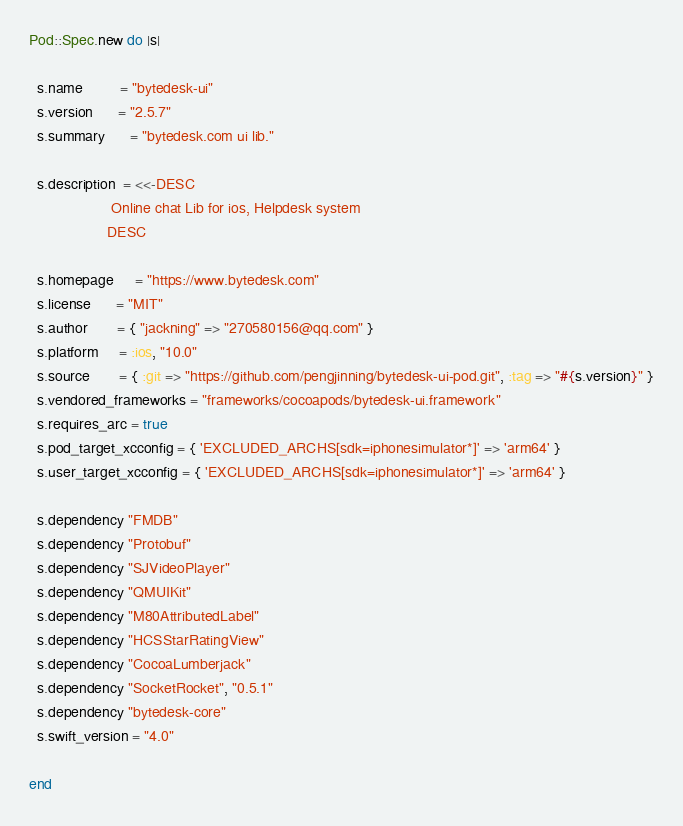Convert code to text. <code><loc_0><loc_0><loc_500><loc_500><_Ruby_>
Pod::Spec.new do |s|

  s.name         = "bytedesk-ui"
  s.version      = "2.5.7"
  s.summary      = "bytedesk.com ui lib."

  s.description  = <<-DESC
                    Online chat Lib for ios, Helpdesk system
                   DESC

  s.homepage     = "https://www.bytedesk.com"
  s.license      = "MIT"
  s.author       = { "jackning" => "270580156@qq.com" }
  s.platform     = :ios, "10.0"
  s.source       = { :git => "https://github.com/pengjinning/bytedesk-ui-pod.git", :tag => "#{s.version}" }
  s.vendored_frameworks = "frameworks/cocoapods/bytedesk-ui.framework"
  s.requires_arc = true
  s.pod_target_xcconfig = { 'EXCLUDED_ARCHS[sdk=iphonesimulator*]' => 'arm64' }
  s.user_target_xcconfig = { 'EXCLUDED_ARCHS[sdk=iphonesimulator*]' => 'arm64' }

  s.dependency "FMDB"
  s.dependency "Protobuf"
  s.dependency "SJVideoPlayer"
  s.dependency "QMUIKit"
  s.dependency "M80AttributedLabel"
  s.dependency "HCSStarRatingView"
  s.dependency "CocoaLumberjack"
  s.dependency "SocketRocket", "0.5.1"
  s.dependency "bytedesk-core"
  s.swift_version = "4.0"

end
</code> 